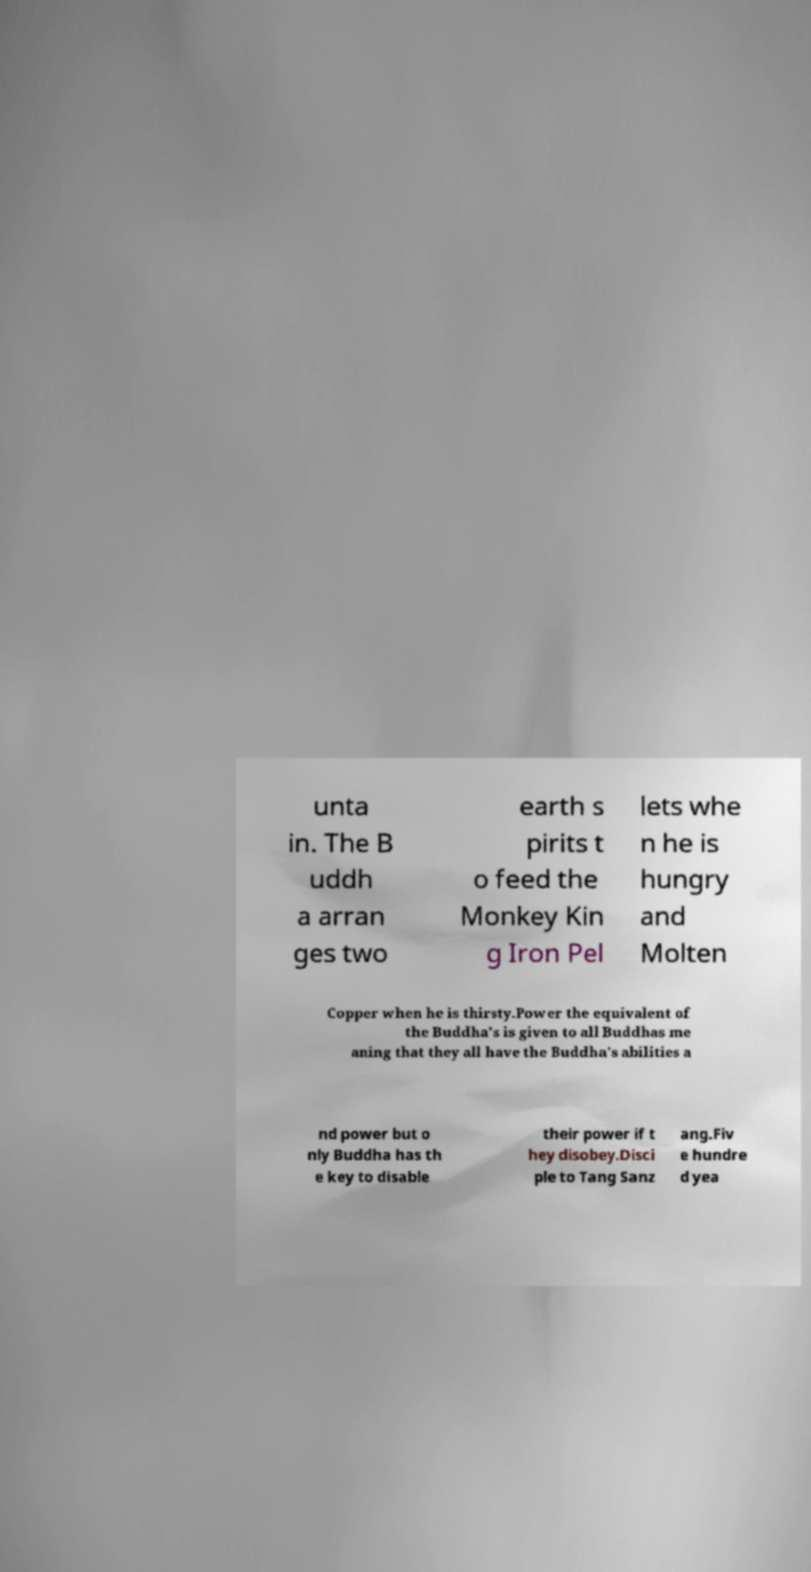For documentation purposes, I need the text within this image transcribed. Could you provide that? unta in. The B uddh a arran ges two earth s pirits t o feed the Monkey Kin g Iron Pel lets whe n he is hungry and Molten Copper when he is thirsty.Power the equivalent of the Buddha's is given to all Buddhas me aning that they all have the Buddha's abilities a nd power but o nly Buddha has th e key to disable their power if t hey disobey.Disci ple to Tang Sanz ang.Fiv e hundre d yea 